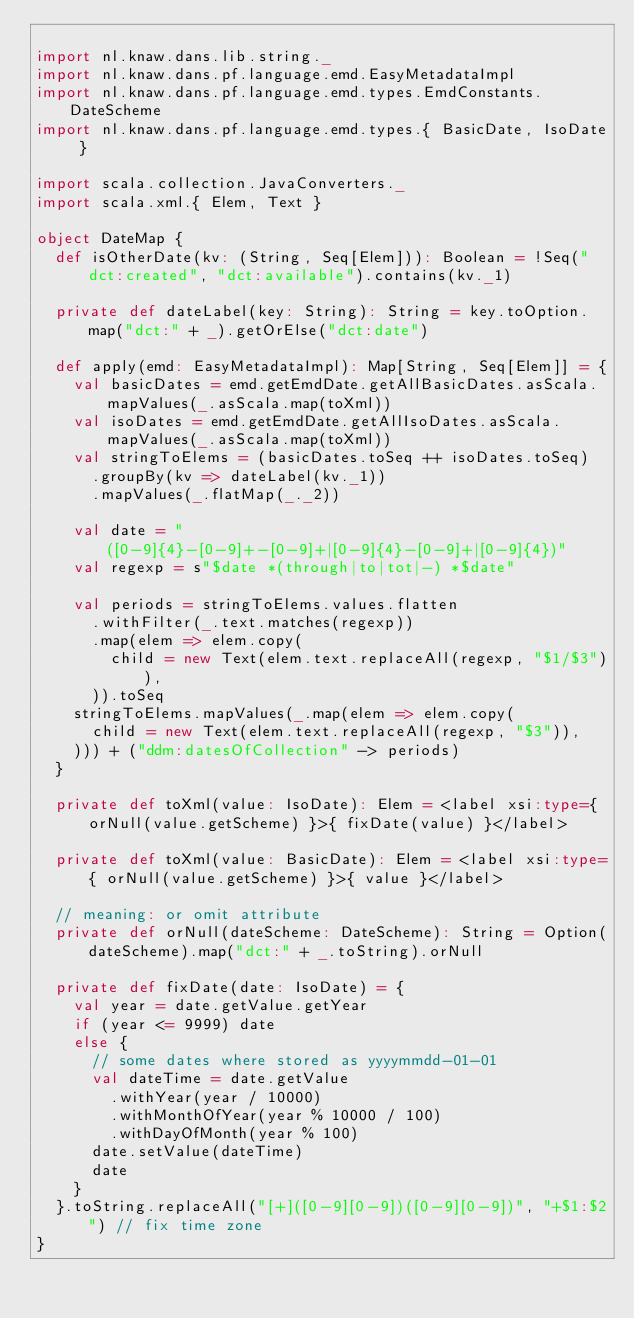Convert code to text. <code><loc_0><loc_0><loc_500><loc_500><_Scala_>
import nl.knaw.dans.lib.string._
import nl.knaw.dans.pf.language.emd.EasyMetadataImpl
import nl.knaw.dans.pf.language.emd.types.EmdConstants.DateScheme
import nl.knaw.dans.pf.language.emd.types.{ BasicDate, IsoDate }

import scala.collection.JavaConverters._
import scala.xml.{ Elem, Text }

object DateMap {
  def isOtherDate(kv: (String, Seq[Elem])): Boolean = !Seq("dct:created", "dct:available").contains(kv._1)

  private def dateLabel(key: String): String = key.toOption.map("dct:" + _).getOrElse("dct:date")

  def apply(emd: EasyMetadataImpl): Map[String, Seq[Elem]] = {
    val basicDates = emd.getEmdDate.getAllBasicDates.asScala.mapValues(_.asScala.map(toXml))
    val isoDates = emd.getEmdDate.getAllIsoDates.asScala.mapValues(_.asScala.map(toXml))
    val stringToElems = (basicDates.toSeq ++ isoDates.toSeq)
      .groupBy(kv => dateLabel(kv._1))
      .mapValues(_.flatMap(_._2))

    val date = "([0-9]{4}-[0-9]+-[0-9]+|[0-9]{4}-[0-9]+|[0-9]{4})"
    val regexp = s"$date *(through|to|tot|-) *$date"

    val periods = stringToElems.values.flatten
      .withFilter(_.text.matches(regexp))
      .map(elem => elem.copy(
        child = new Text(elem.text.replaceAll(regexp, "$1/$3")),
      )).toSeq
    stringToElems.mapValues(_.map(elem => elem.copy(
      child = new Text(elem.text.replaceAll(regexp, "$3")),
    ))) + ("ddm:datesOfCollection" -> periods)
  }

  private def toXml(value: IsoDate): Elem = <label xsi:type={ orNull(value.getScheme) }>{ fixDate(value) }</label>

  private def toXml(value: BasicDate): Elem = <label xsi:type={ orNull(value.getScheme) }>{ value }</label>

  // meaning: or omit attribute
  private def orNull(dateScheme: DateScheme): String = Option(dateScheme).map("dct:" + _.toString).orNull

  private def fixDate(date: IsoDate) = {
    val year = date.getValue.getYear
    if (year <= 9999) date
    else {
      // some dates where stored as yyyymmdd-01-01
      val dateTime = date.getValue
        .withYear(year / 10000)
        .withMonthOfYear(year % 10000 / 100)
        .withDayOfMonth(year % 100)
      date.setValue(dateTime)
      date
    }
  }.toString.replaceAll("[+]([0-9][0-9])([0-9][0-9])", "+$1:$2") // fix time zone
}
</code> 